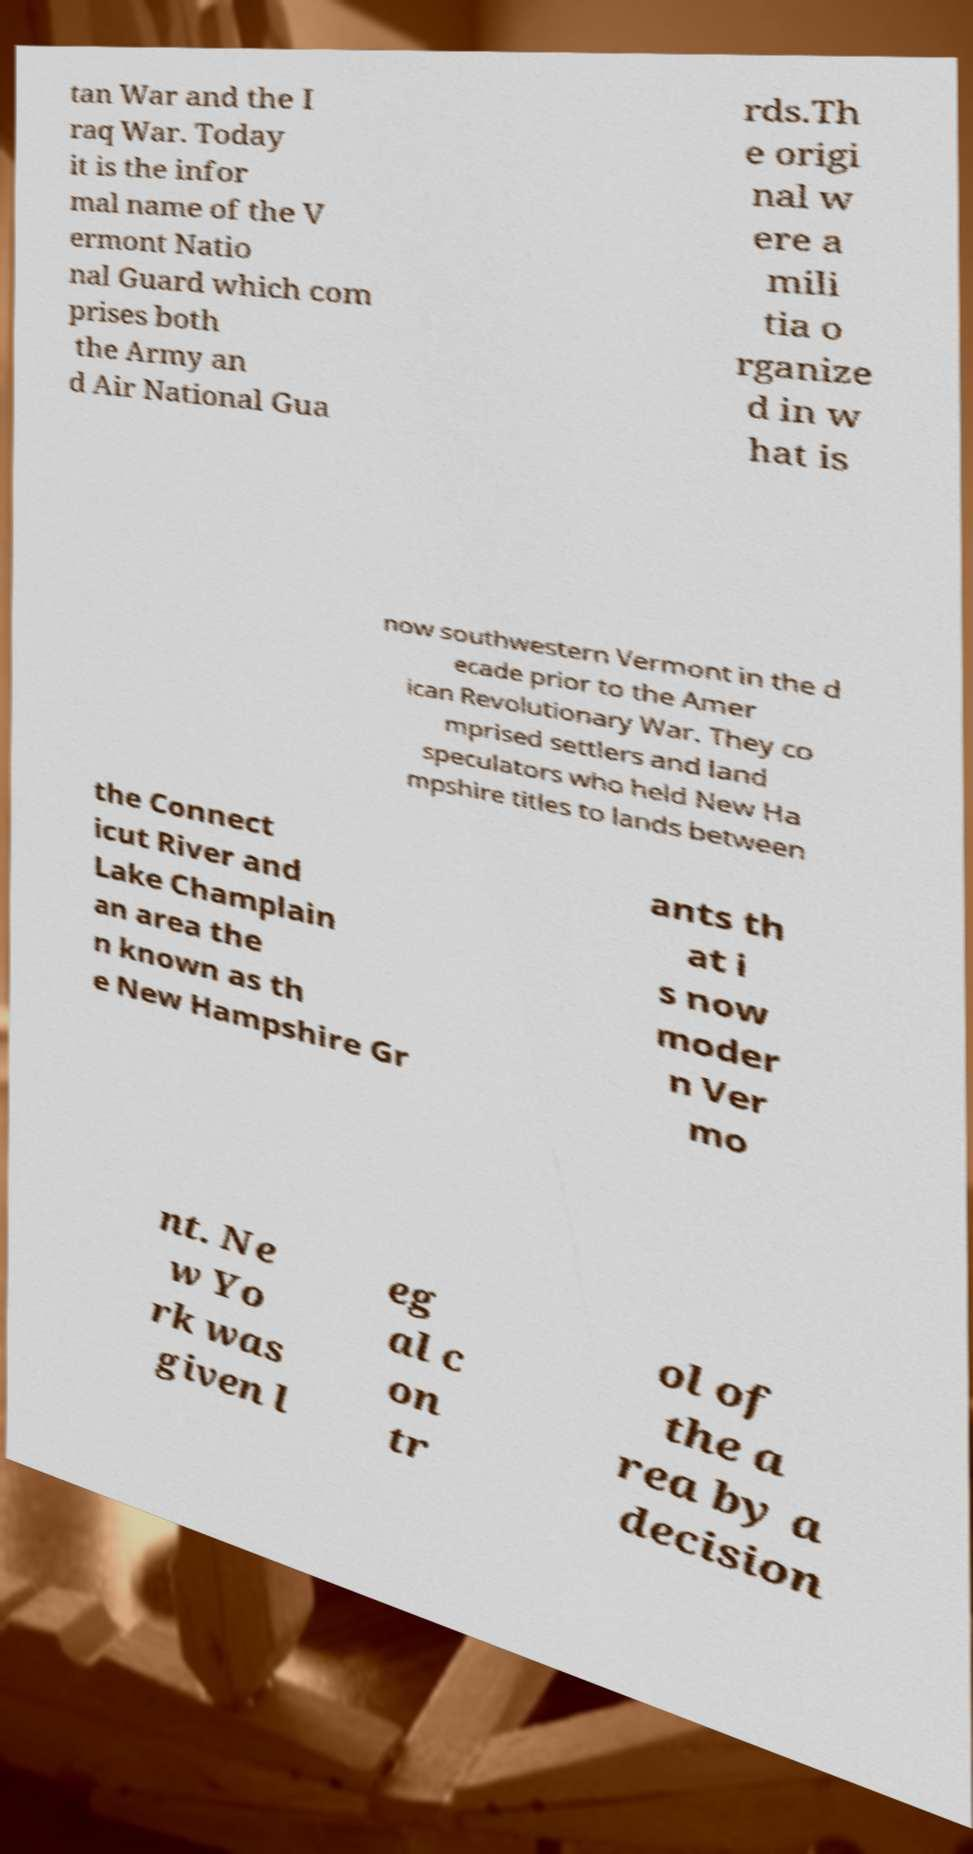For documentation purposes, I need the text within this image transcribed. Could you provide that? tan War and the I raq War. Today it is the infor mal name of the V ermont Natio nal Guard which com prises both the Army an d Air National Gua rds.Th e origi nal w ere a mili tia o rganize d in w hat is now southwestern Vermont in the d ecade prior to the Amer ican Revolutionary War. They co mprised settlers and land speculators who held New Ha mpshire titles to lands between the Connect icut River and Lake Champlain an area the n known as th e New Hampshire Gr ants th at i s now moder n Ver mo nt. Ne w Yo rk was given l eg al c on tr ol of the a rea by a decision 